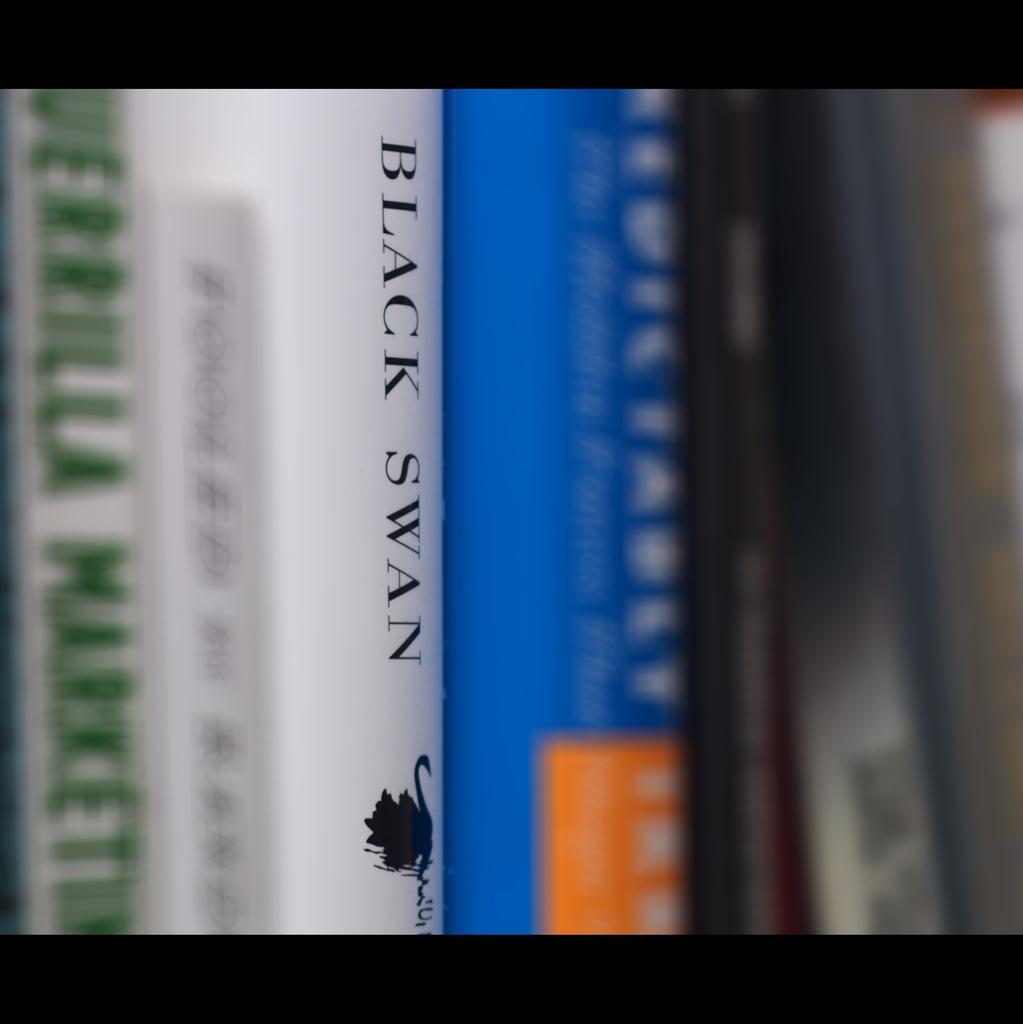Provide a one-sentence caption for the provided image. Several books side by side and Black Swan with white book jacket in the middle. 